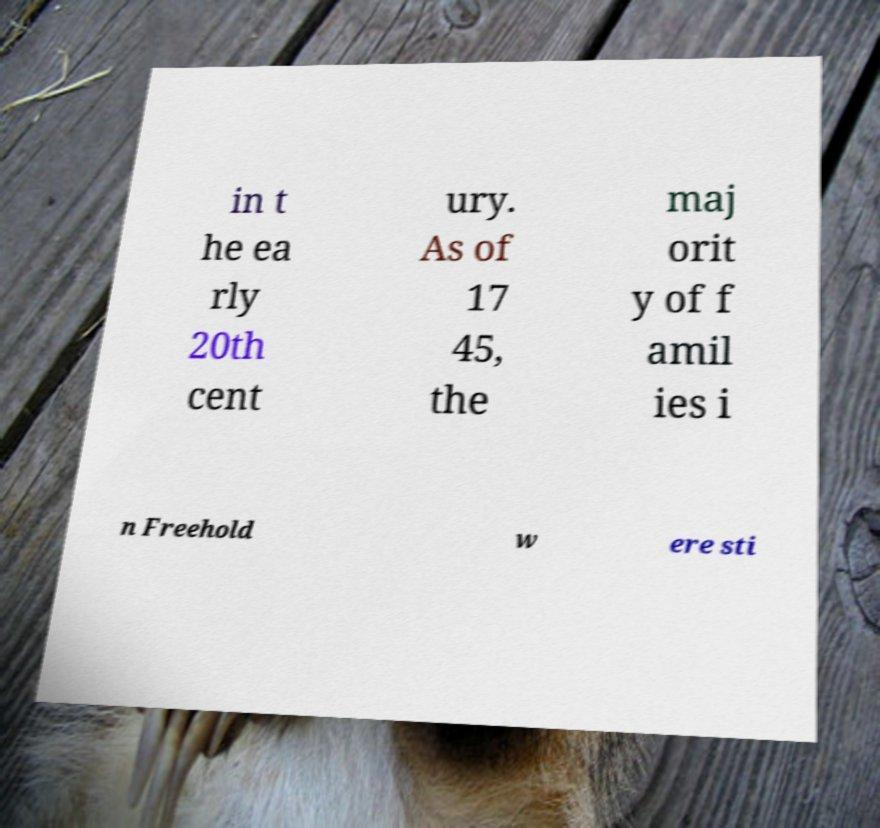For documentation purposes, I need the text within this image transcribed. Could you provide that? in t he ea rly 20th cent ury. As of 17 45, the maj orit y of f amil ies i n Freehold w ere sti 